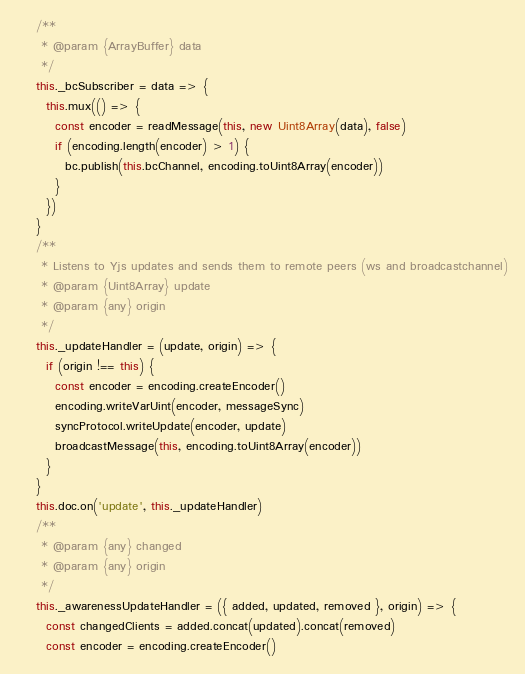<code> <loc_0><loc_0><loc_500><loc_500><_JavaScript_>    /**
     * @param {ArrayBuffer} data
     */
    this._bcSubscriber = data => {
      this.mux(() => {
        const encoder = readMessage(this, new Uint8Array(data), false)
        if (encoding.length(encoder) > 1) {
          bc.publish(this.bcChannel, encoding.toUint8Array(encoder))
        }
      })
    }
    /**
     * Listens to Yjs updates and sends them to remote peers (ws and broadcastchannel)
     * @param {Uint8Array} update
     * @param {any} origin
     */
    this._updateHandler = (update, origin) => {
      if (origin !== this) {
        const encoder = encoding.createEncoder()
        encoding.writeVarUint(encoder, messageSync)
        syncProtocol.writeUpdate(encoder, update)
        broadcastMessage(this, encoding.toUint8Array(encoder))
      }
    }
    this.doc.on('update', this._updateHandler)
    /**
     * @param {any} changed
     * @param {any} origin
     */
    this._awarenessUpdateHandler = ({ added, updated, removed }, origin) => {
      const changedClients = added.concat(updated).concat(removed)
      const encoder = encoding.createEncoder()</code> 